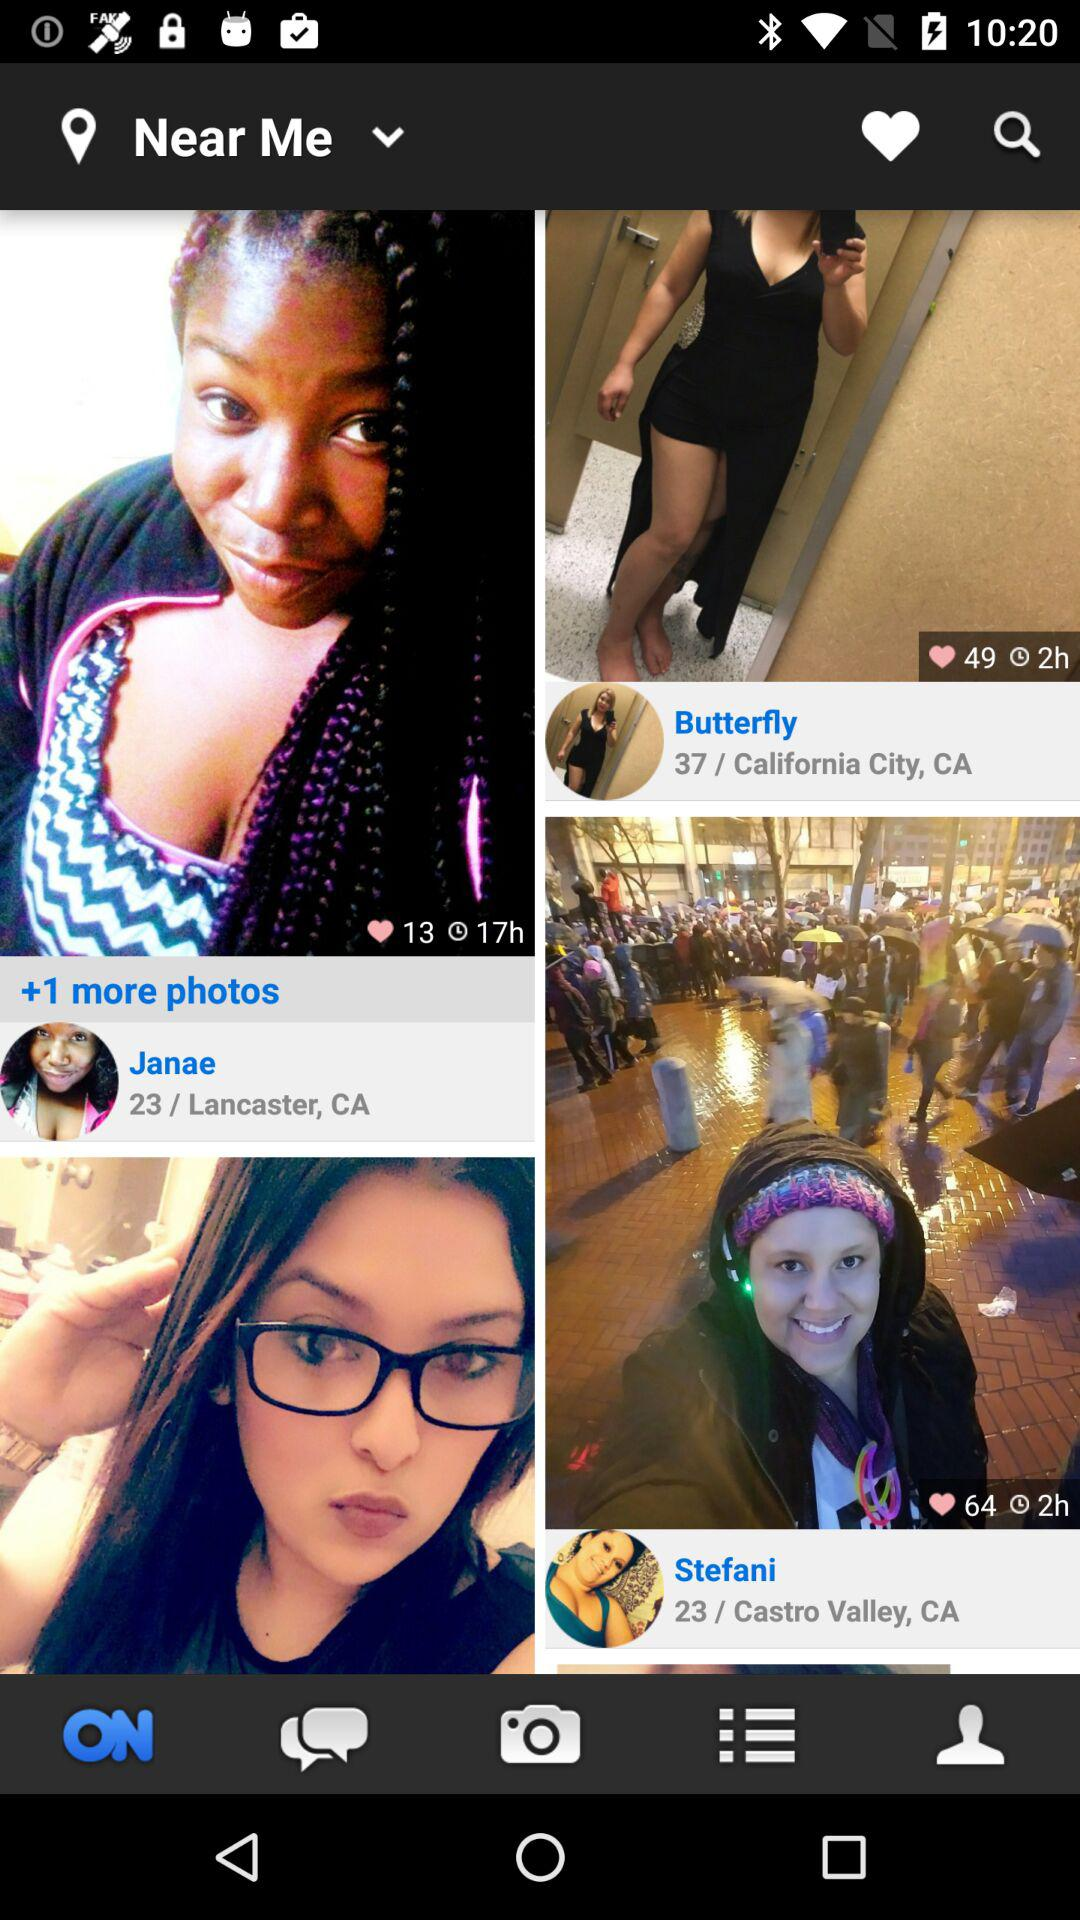How many likes are there on the picture of Janae? There are 13 likes on the picture of Janae. 